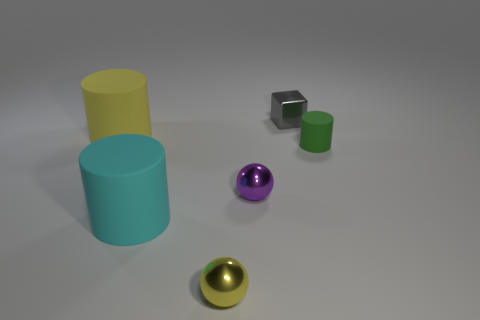Subtract 1 cubes. How many cubes are left? 0 Subtract all big yellow cylinders. How many cylinders are left? 2 Add 1 small gray shiny cubes. How many objects exist? 7 Subtract all spheres. How many objects are left? 4 Subtract all yellow metal objects. Subtract all tiny yellow metal objects. How many objects are left? 4 Add 3 small rubber objects. How many small rubber objects are left? 4 Add 5 tiny cyan shiny cylinders. How many tiny cyan shiny cylinders exist? 5 Subtract all yellow cylinders. How many cylinders are left? 2 Subtract 1 green cylinders. How many objects are left? 5 Subtract all green cubes. Subtract all green balls. How many cubes are left? 1 